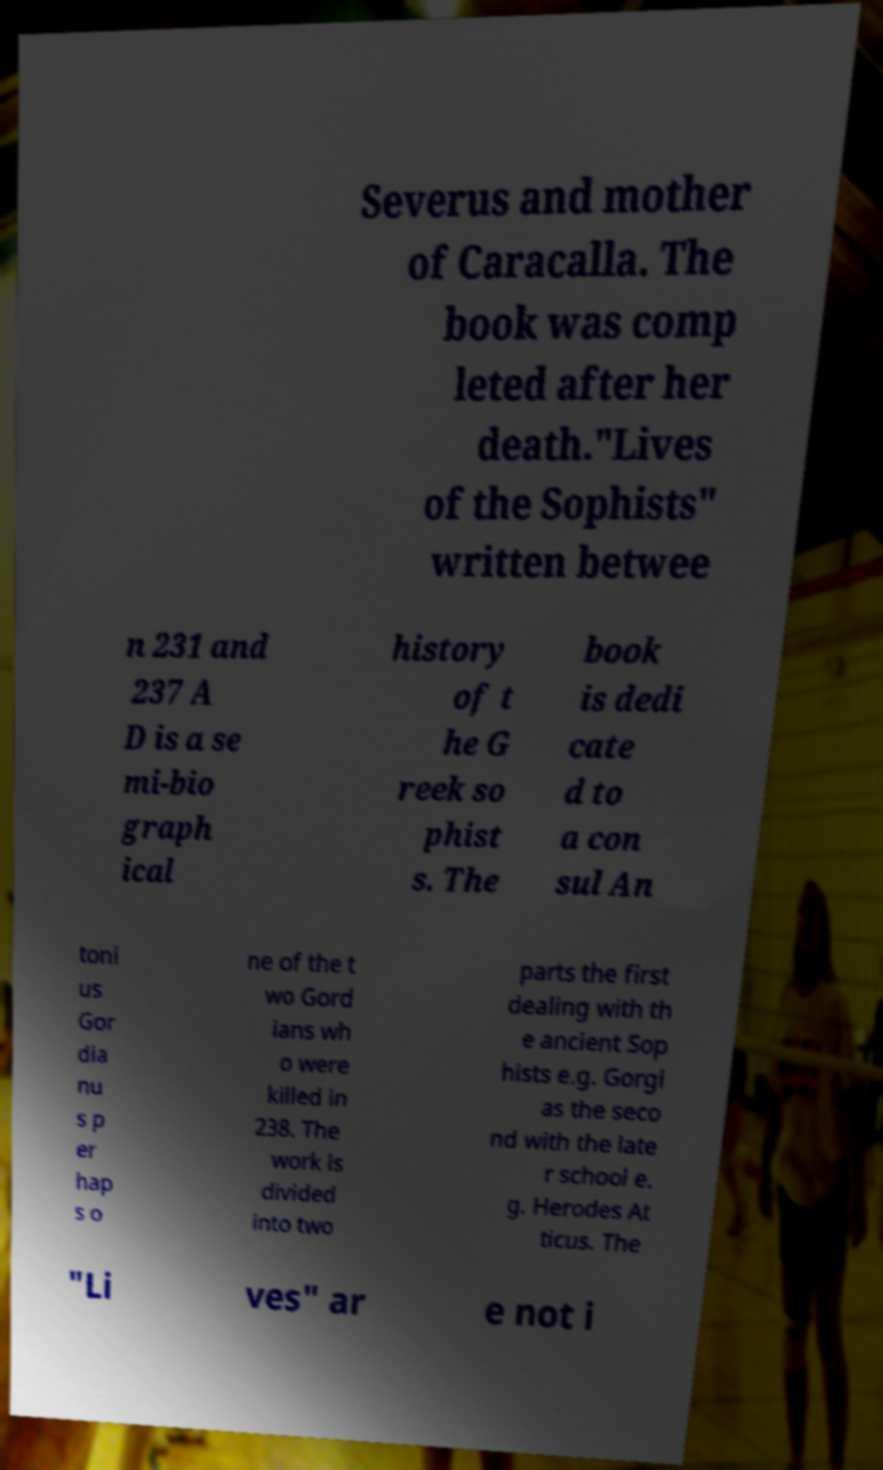I need the written content from this picture converted into text. Can you do that? Severus and mother of Caracalla. The book was comp leted after her death."Lives of the Sophists" written betwee n 231 and 237 A D is a se mi-bio graph ical history of t he G reek so phist s. The book is dedi cate d to a con sul An toni us Gor dia nu s p er hap s o ne of the t wo Gord ians wh o were killed in 238. The work is divided into two parts the first dealing with th e ancient Sop hists e.g. Gorgi as the seco nd with the late r school e. g. Herodes At ticus. The "Li ves" ar e not i 